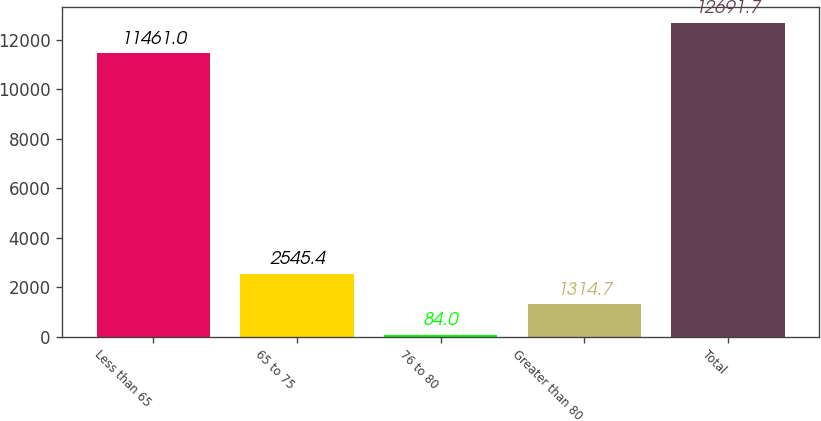Convert chart. <chart><loc_0><loc_0><loc_500><loc_500><bar_chart><fcel>Less than 65<fcel>65 to 75<fcel>76 to 80<fcel>Greater than 80<fcel>Total<nl><fcel>11461<fcel>2545.4<fcel>84<fcel>1314.7<fcel>12691.7<nl></chart> 